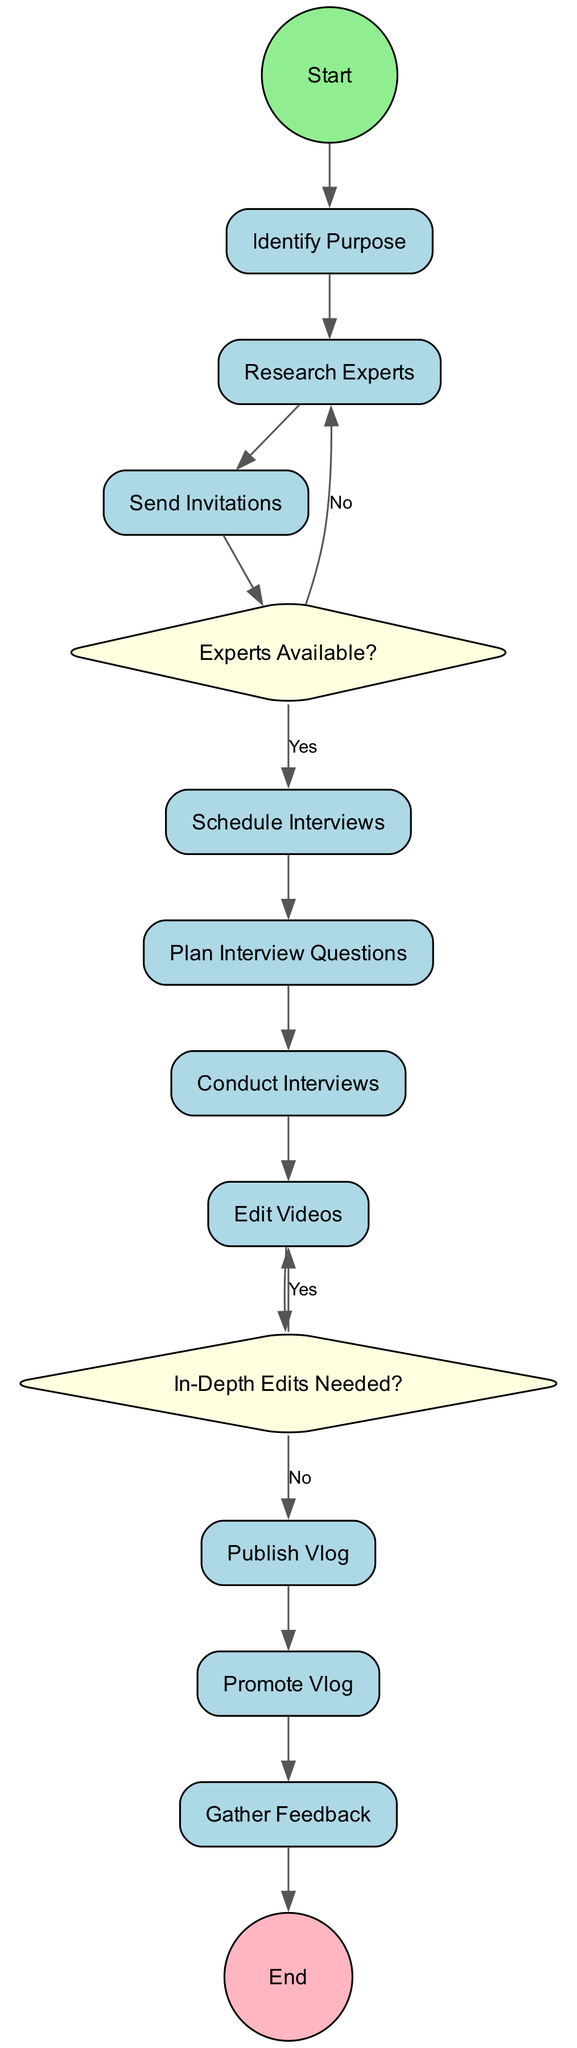What is the first activity in the diagram? The diagram starts with the "Identify Purpose" activity, which is the first step outlined in the flow of activities.
Answer: Identify Purpose How many decision nodes are present in the diagram? There are 2 decision nodes: "Experts Available?" and "In-Depth Edits Needed?". This can be counted directly from the decision nodes included in the diagram.
Answer: 2 What happens if the experts are not available? If the experts are not available, the flow goes back to the "Research Experts" activity, indicating that further experts need to be researched.
Answer: Research Experts Which activity comes after "Conduct Interviews"? After "Conduct Interviews", the next activity is "Edit Videos", showing the progression from performing interviews to editing the recorded material.
Answer: Edit Videos What is the condition leading from "In-Depth Edits Needed?" to "Edit Videos"? The condition is "Yes," which indicates that if in-depth edits are needed, the flow returns to "Edit Videos" to make those adjustments.
Answer: Yes What is the final activity in the diagram? The final activity is "Gather Feedback", which is the last step after promoting the vlog, completing the entire process outlined in the diagram.
Answer: Gather Feedback What is the purpose of the "Send Invitations" activity? The purpose of the "Send Invitations" activity is to contact and invite selected health experts to participate in the vlog about Chagas disease prevention.
Answer: Contact and invite selected experts What activity is scheduled directly after "Schedule Interviews"? The "Plan Interview Questions" activity follows directly after "Schedule Interviews," indicating that planned questions will be prepared after setting interview times.
Answer: Plan Interview Questions 